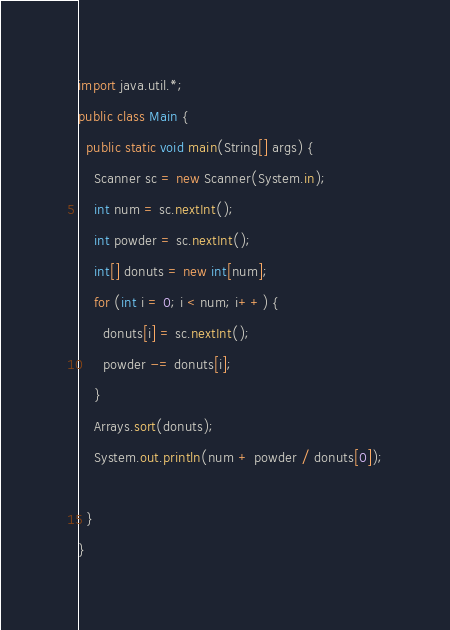Convert code to text. <code><loc_0><loc_0><loc_500><loc_500><_Java_>import java.util.*;
public class Main {
  public static void main(String[] args) {
    Scanner sc = new Scanner(System.in);
    int num = sc.nextInt();
    int powder = sc.nextInt();
    int[] donuts = new int[num];
    for (int i = 0; i < num; i++) {
      donuts[i] = sc.nextInt();
      powder -= donuts[i];
    }
    Arrays.sort(donuts);
    System.out.println(num + powder / donuts[0]);
    
  }
}</code> 